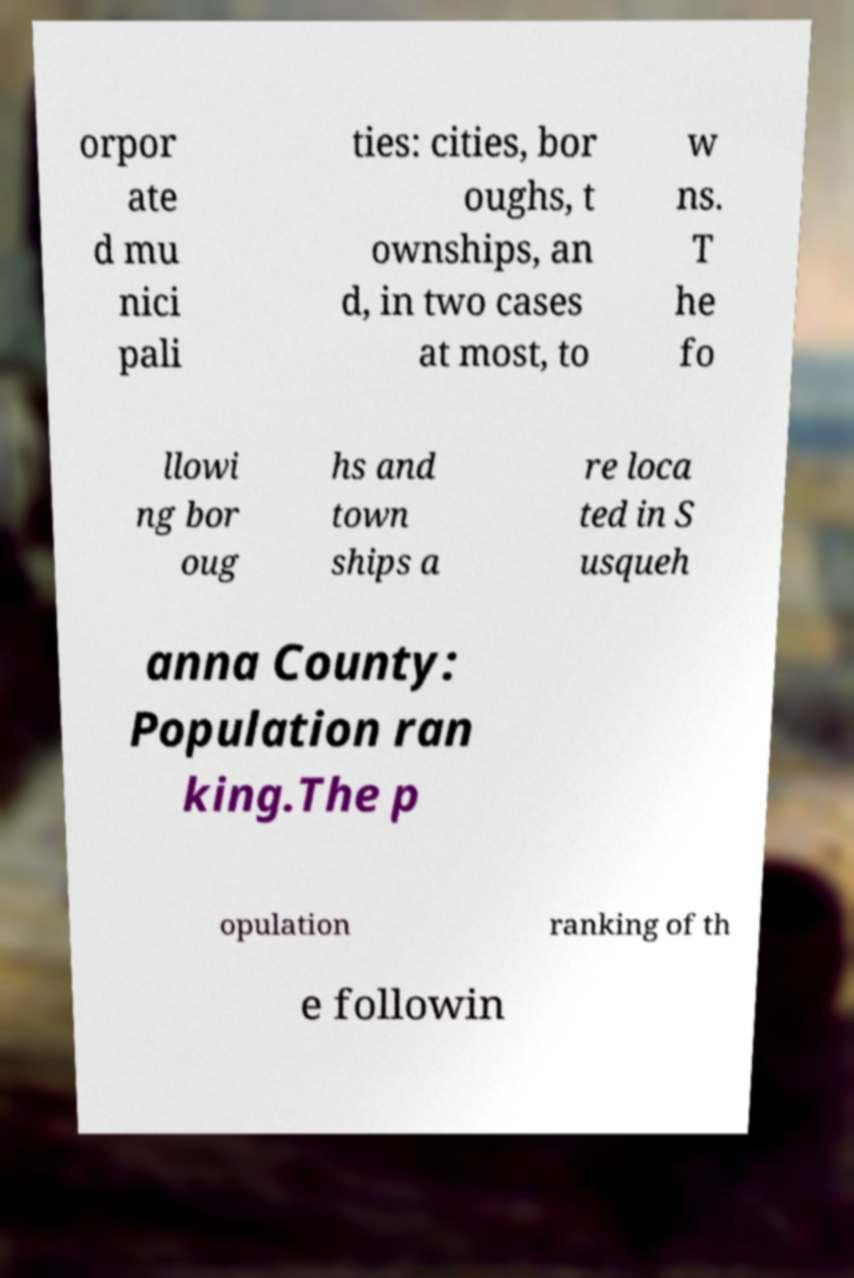Can you accurately transcribe the text from the provided image for me? orpor ate d mu nici pali ties: cities, bor oughs, t ownships, an d, in two cases at most, to w ns. T he fo llowi ng bor oug hs and town ships a re loca ted in S usqueh anna County: Population ran king.The p opulation ranking of th e followin 